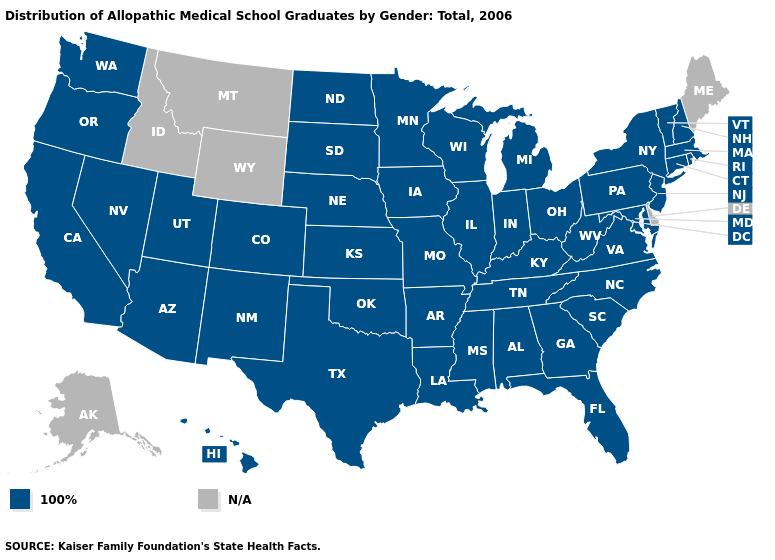Does the map have missing data?
Keep it brief. Yes. What is the lowest value in states that border North Carolina?
Write a very short answer. 100%. What is the value of New York?
Give a very brief answer. 100%. What is the highest value in states that border Indiana?
Short answer required. 100%. Which states have the lowest value in the West?
Short answer required. Arizona, California, Colorado, Hawaii, Nevada, New Mexico, Oregon, Utah, Washington. Which states have the lowest value in the South?
Give a very brief answer. Alabama, Arkansas, Florida, Georgia, Kentucky, Louisiana, Maryland, Mississippi, North Carolina, Oklahoma, South Carolina, Tennessee, Texas, Virginia, West Virginia. Does the first symbol in the legend represent the smallest category?
Be succinct. Yes. What is the value of Nevada?
Concise answer only. 100%. Which states have the lowest value in the USA?
Write a very short answer. Alabama, Arizona, Arkansas, California, Colorado, Connecticut, Florida, Georgia, Hawaii, Illinois, Indiana, Iowa, Kansas, Kentucky, Louisiana, Maryland, Massachusetts, Michigan, Minnesota, Mississippi, Missouri, Nebraska, Nevada, New Hampshire, New Jersey, New Mexico, New York, North Carolina, North Dakota, Ohio, Oklahoma, Oregon, Pennsylvania, Rhode Island, South Carolina, South Dakota, Tennessee, Texas, Utah, Vermont, Virginia, Washington, West Virginia, Wisconsin. Among the states that border New York , which have the highest value?
Keep it brief. Connecticut, Massachusetts, New Jersey, Pennsylvania, Vermont. Does the map have missing data?
Short answer required. Yes. 